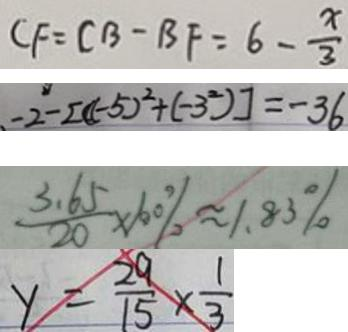Convert formula to latex. <formula><loc_0><loc_0><loc_500><loc_500>C F = C B - B F = 6 - \frac { x } { 3 } 
 - 2 - [ ( - 5 ) ^ { 2 } + ( - 3 ^ { 2 } ) ] = - 3 6 
 \frac { 3 . 6 5 } { 2 0 } \times 1 0 0 \% \approx 1 . 8 3 \% 
 y = \frac { 2 9 } { 1 5 } \times \frac { 1 } { 3 }</formula> 